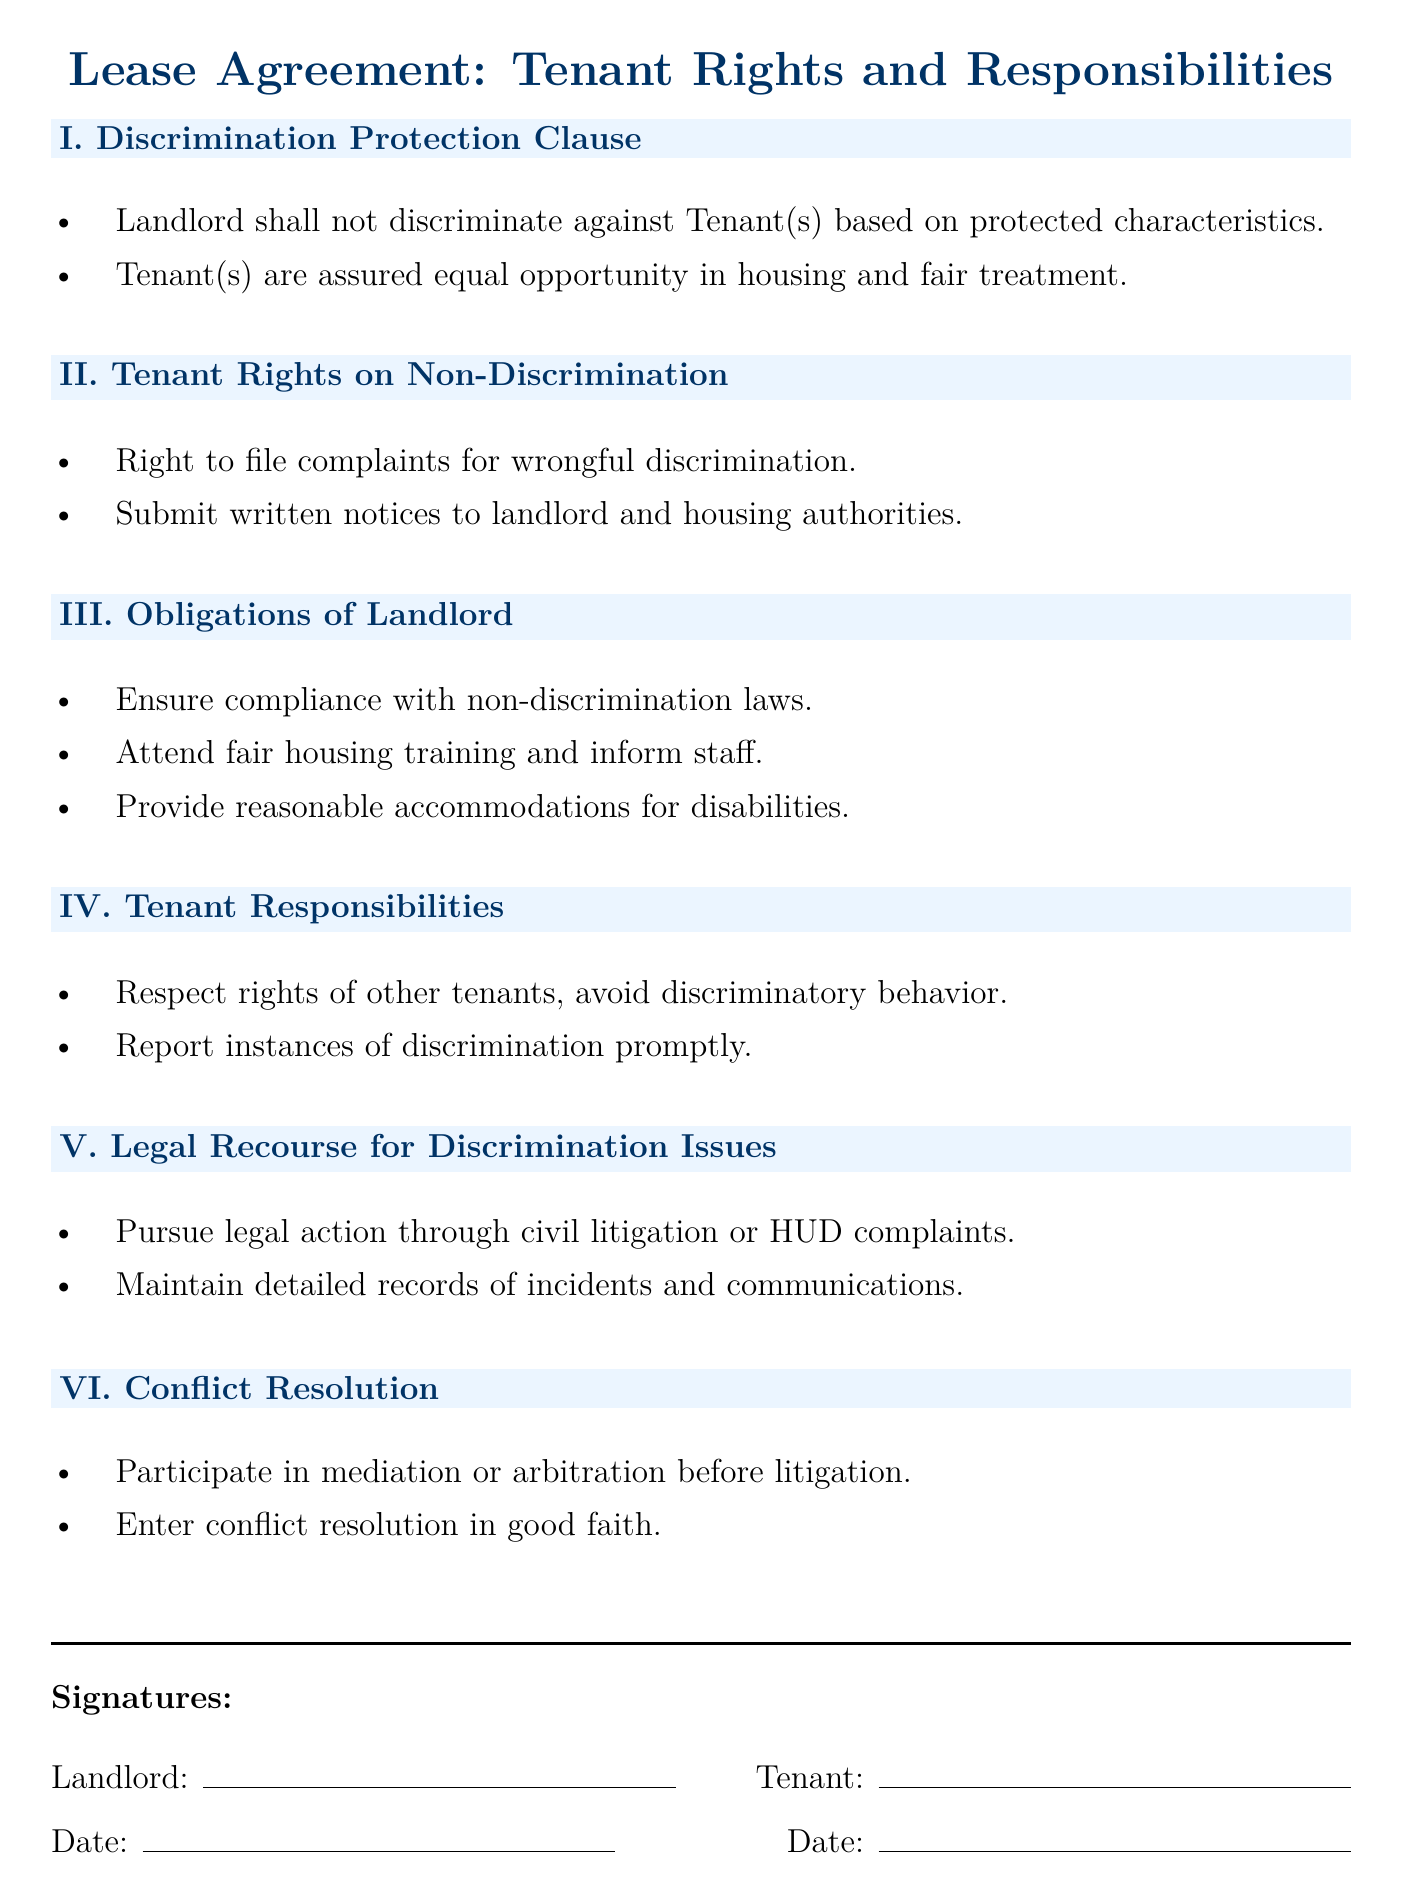What is the title of the document? The title can be found at the top of the rendered document, indicating the subject matter it addresses.
Answer: Lease Agreement: Tenant Rights and Responsibilities What is the first clause in the document? The first clause listed in the document is the section heading about discrimination protection.
Answer: I. Discrimination Protection Clause What obligation does the landlord have regarding staff training? This obligation is specified under the "Obligations of Landlord" section, detailing what the landlord must do to comply with anti-discrimination laws.
Answer: Attend fair housing training and inform staff What rights do tenants have concerning discrimination? This is specified in the "Tenant Rights on Non-Discrimination" section, detailing the rights tenants have if they experience discrimination.
Answer: Right to file complaints for wrongful discrimination What must tenants do if they observe discriminatory behavior? This is stated under the "Tenant Responsibilities" section, outlining what tenants need to do in such cases.
Answer: Report instances of discrimination promptly What legal recourse is available for discrimination issues? This information is found in the "Legal Recourse for Discrimination Issues" section, outlining the options available to tenants.
Answer: Pursue legal action through civil litigation or HUD complaints What is required before entering litigation according to the document? This requirement is specified in the "Conflict Resolution" section, indicating the process to follow before legal actions are taken.
Answer: Participate in mediation or arbitration before litigation How many main sections are there in the document? Counting the sections will reveal the total number of distinct areas addressed in the lease agreement.
Answer: Six main sections 